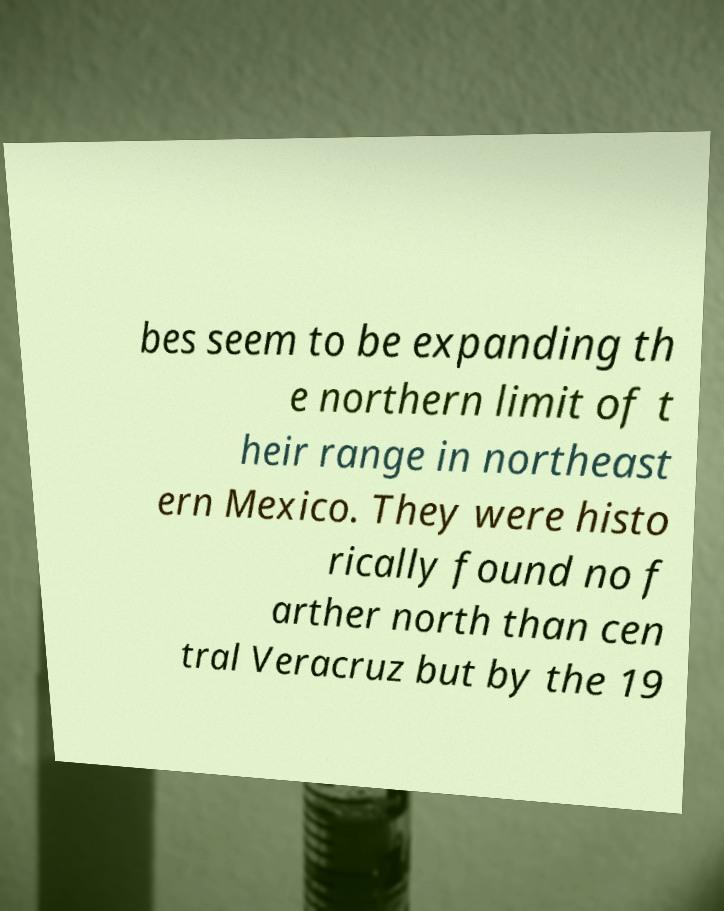Can you accurately transcribe the text from the provided image for me? bes seem to be expanding th e northern limit of t heir range in northeast ern Mexico. They were histo rically found no f arther north than cen tral Veracruz but by the 19 